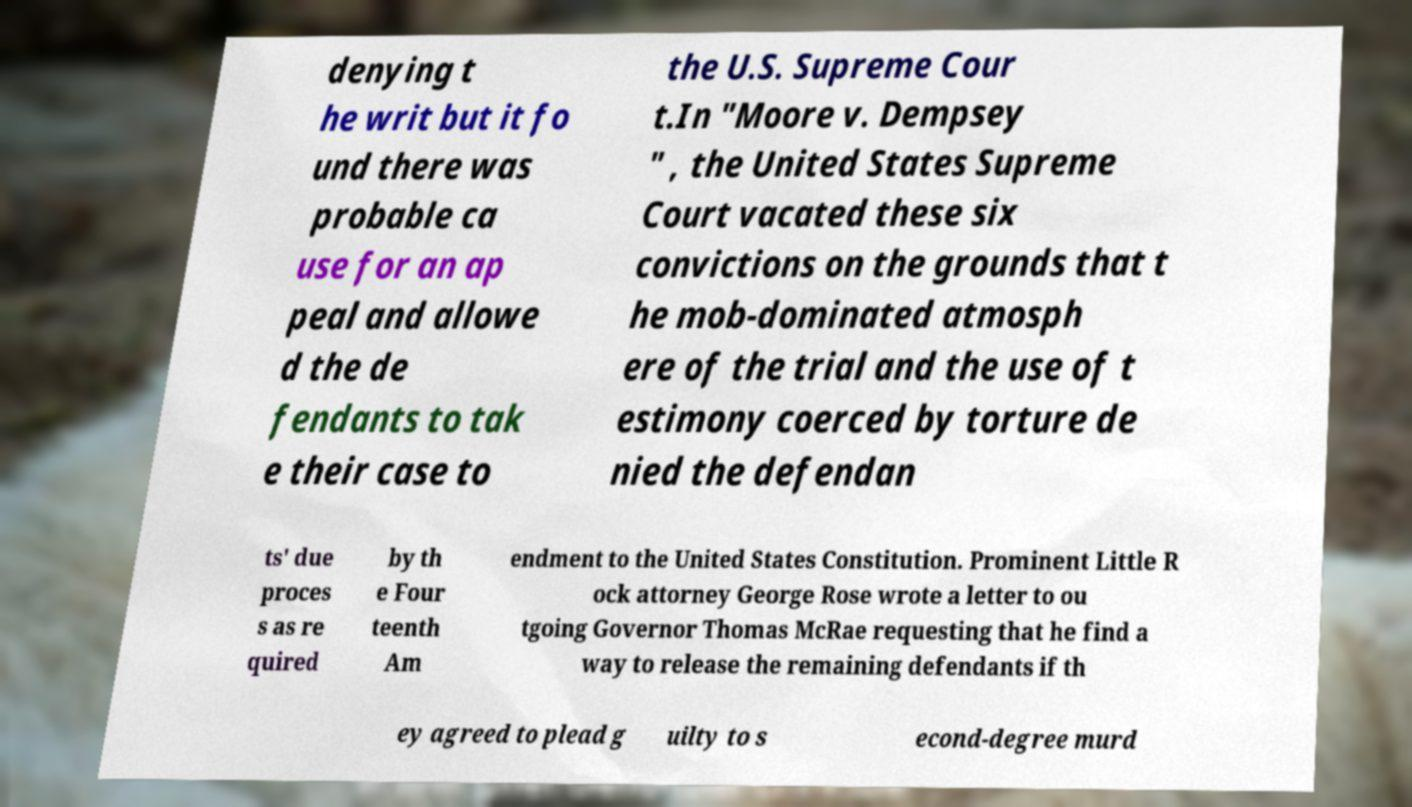Could you extract and type out the text from this image? denying t he writ but it fo und there was probable ca use for an ap peal and allowe d the de fendants to tak e their case to the U.S. Supreme Cour t.In "Moore v. Dempsey " , the United States Supreme Court vacated these six convictions on the grounds that t he mob-dominated atmosph ere of the trial and the use of t estimony coerced by torture de nied the defendan ts' due proces s as re quired by th e Four teenth Am endment to the United States Constitution. Prominent Little R ock attorney George Rose wrote a letter to ou tgoing Governor Thomas McRae requesting that he find a way to release the remaining defendants if th ey agreed to plead g uilty to s econd-degree murd 